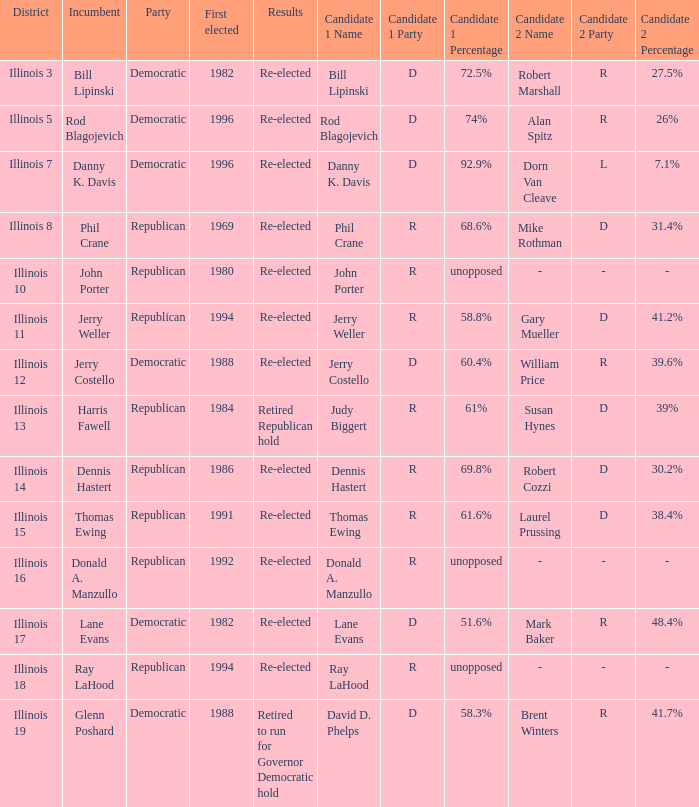What district was John Porter elected in? Illinois 10. 